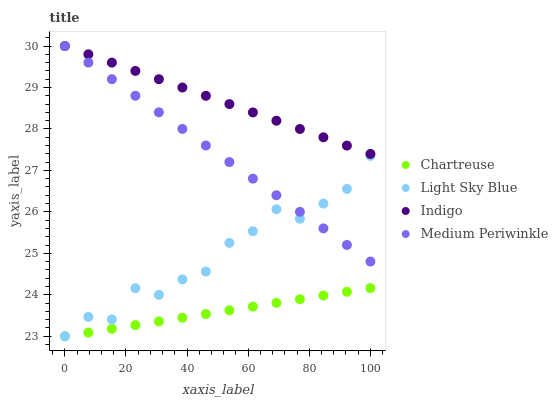Does Chartreuse have the minimum area under the curve?
Answer yes or no. Yes. Does Indigo have the maximum area under the curve?
Answer yes or no. Yes. Does Light Sky Blue have the minimum area under the curve?
Answer yes or no. No. Does Light Sky Blue have the maximum area under the curve?
Answer yes or no. No. Is Chartreuse the smoothest?
Answer yes or no. Yes. Is Light Sky Blue the roughest?
Answer yes or no. Yes. Is Light Sky Blue the smoothest?
Answer yes or no. No. Is Chartreuse the roughest?
Answer yes or no. No. Does Chartreuse have the lowest value?
Answer yes or no. Yes. Does Indigo have the lowest value?
Answer yes or no. No. Does Indigo have the highest value?
Answer yes or no. Yes. Does Light Sky Blue have the highest value?
Answer yes or no. No. Is Chartreuse less than Medium Periwinkle?
Answer yes or no. Yes. Is Indigo greater than Chartreuse?
Answer yes or no. Yes. Does Light Sky Blue intersect Chartreuse?
Answer yes or no. Yes. Is Light Sky Blue less than Chartreuse?
Answer yes or no. No. Is Light Sky Blue greater than Chartreuse?
Answer yes or no. No. Does Chartreuse intersect Medium Periwinkle?
Answer yes or no. No. 